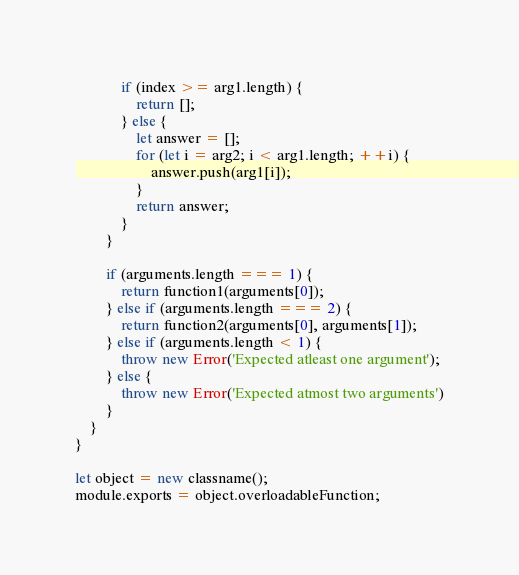Convert code to text. <code><loc_0><loc_0><loc_500><loc_500><_JavaScript_>            if (index >= arg1.length) {
                return [];
            } else {
                let answer = [];
                for (let i = arg2; i < arg1.length; ++i) {
                    answer.push(arg1[i]);
                }
                return answer;
            }
        }

        if (arguments.length === 1) {
            return function1(arguments[0]);
        } else if (arguments.length === 2) {
            return function2(arguments[0], arguments[1]);
        } else if (arguments.length < 1) {
            throw new Error('Expected atleast one argument');
        } else {
            throw new Error('Expected atmost two arguments')
        }
    }
}

let object = new classname();
module.exports = object.overloadableFunction;</code> 